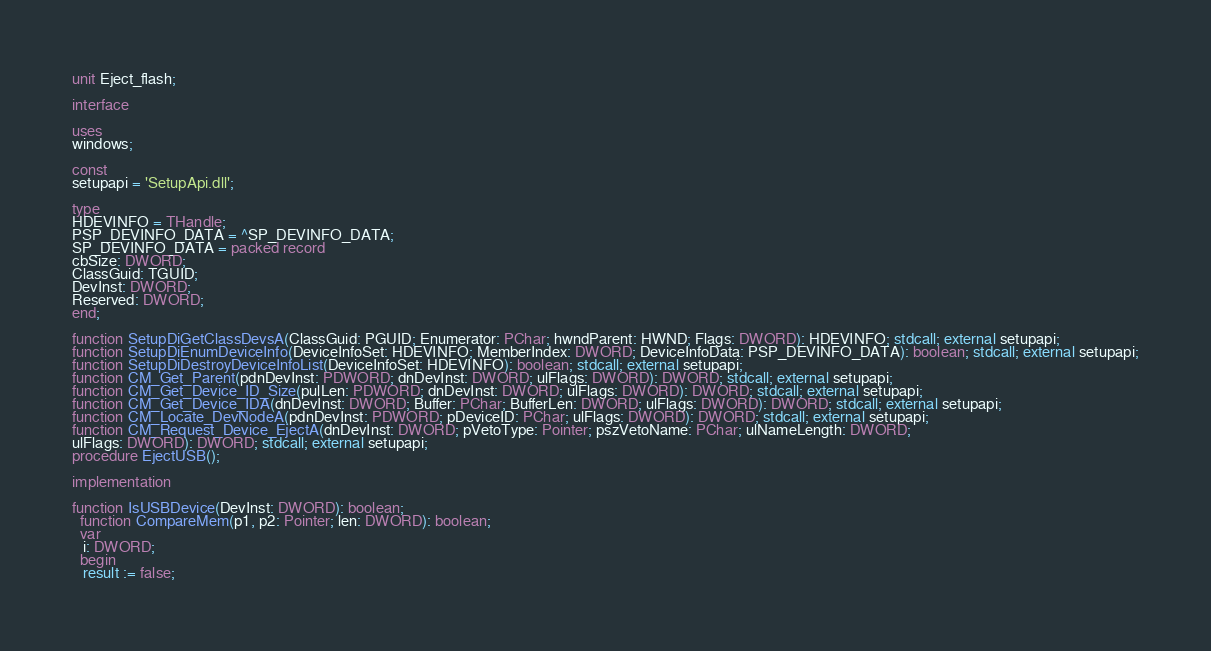Convert code to text. <code><loc_0><loc_0><loc_500><loc_500><_Pascal_>unit Eject_flash;

interface

uses
windows;

const
setupapi = 'SetupApi.dll';

type
HDEVINFO = THandle;
PSP_DEVINFO_DATA = ^SP_DEVINFO_DATA;
SP_DEVINFO_DATA = packed record
cbSize: DWORD;
ClassGuid: TGUID;
DevInst: DWORD;
Reserved: DWORD;
end;

function SetupDiGetClassDevsA(ClassGuid: PGUID; Enumerator: PChar; hwndParent: HWND; Flags: DWORD): HDEVINFO; stdcall; external setupapi;
function SetupDiEnumDeviceInfo(DeviceInfoSet: HDEVINFO; MemberIndex: DWORD; DeviceInfoData: PSP_DEVINFO_DATA): boolean; stdcall; external setupapi;
function SetupDiDestroyDeviceInfoList(DeviceInfoSet: HDEVINFO): boolean; stdcall; external setupapi;
function CM_Get_Parent(pdnDevInst: PDWORD; dnDevInst: DWORD; ulFlags: DWORD): DWORD; stdcall; external setupapi;
function CM_Get_Device_ID_Size(pulLen: PDWORD; dnDevInst: DWORD; ulFlags: DWORD): DWORD; stdcall; external setupapi;
function CM_Get_Device_IDA(dnDevInst: DWORD; Buffer: PChar; BufferLen: DWORD; ulFlags: DWORD): DWORD; stdcall; external setupapi;
function CM_Locate_DevNodeA(pdnDevInst: PDWORD; pDeviceID: PChar; ulFlags: DWORD): DWORD; stdcall; external setupapi;
function CM_Request_Device_EjectA(dnDevInst: DWORD; pVetoType: Pointer; pszVetoName: PChar; ulNameLength: DWORD;
ulFlags: DWORD): DWORD; stdcall; external setupapi;
procedure EjectUSB();

implementation

function IsUSBDevice(DevInst: DWORD): boolean;
  function CompareMem(p1, p2: Pointer; len: DWORD): boolean;
  var
   i: DWORD;
  begin
   result := false;</code> 